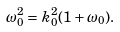<formula> <loc_0><loc_0><loc_500><loc_500>\omega _ { 0 } ^ { 2 } = k _ { 0 } ^ { 2 } ( 1 + \omega _ { 0 } ) .</formula> 